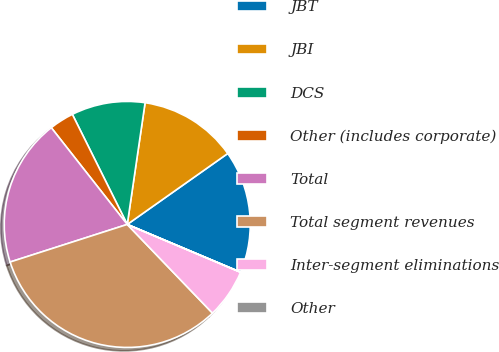Convert chart. <chart><loc_0><loc_0><loc_500><loc_500><pie_chart><fcel>JBT<fcel>JBI<fcel>DCS<fcel>Other (includes corporate)<fcel>Total<fcel>Total segment revenues<fcel>Inter-segment eliminations<fcel>Other<nl><fcel>16.13%<fcel>12.9%<fcel>9.68%<fcel>3.23%<fcel>19.35%<fcel>32.24%<fcel>6.46%<fcel>0.01%<nl></chart> 